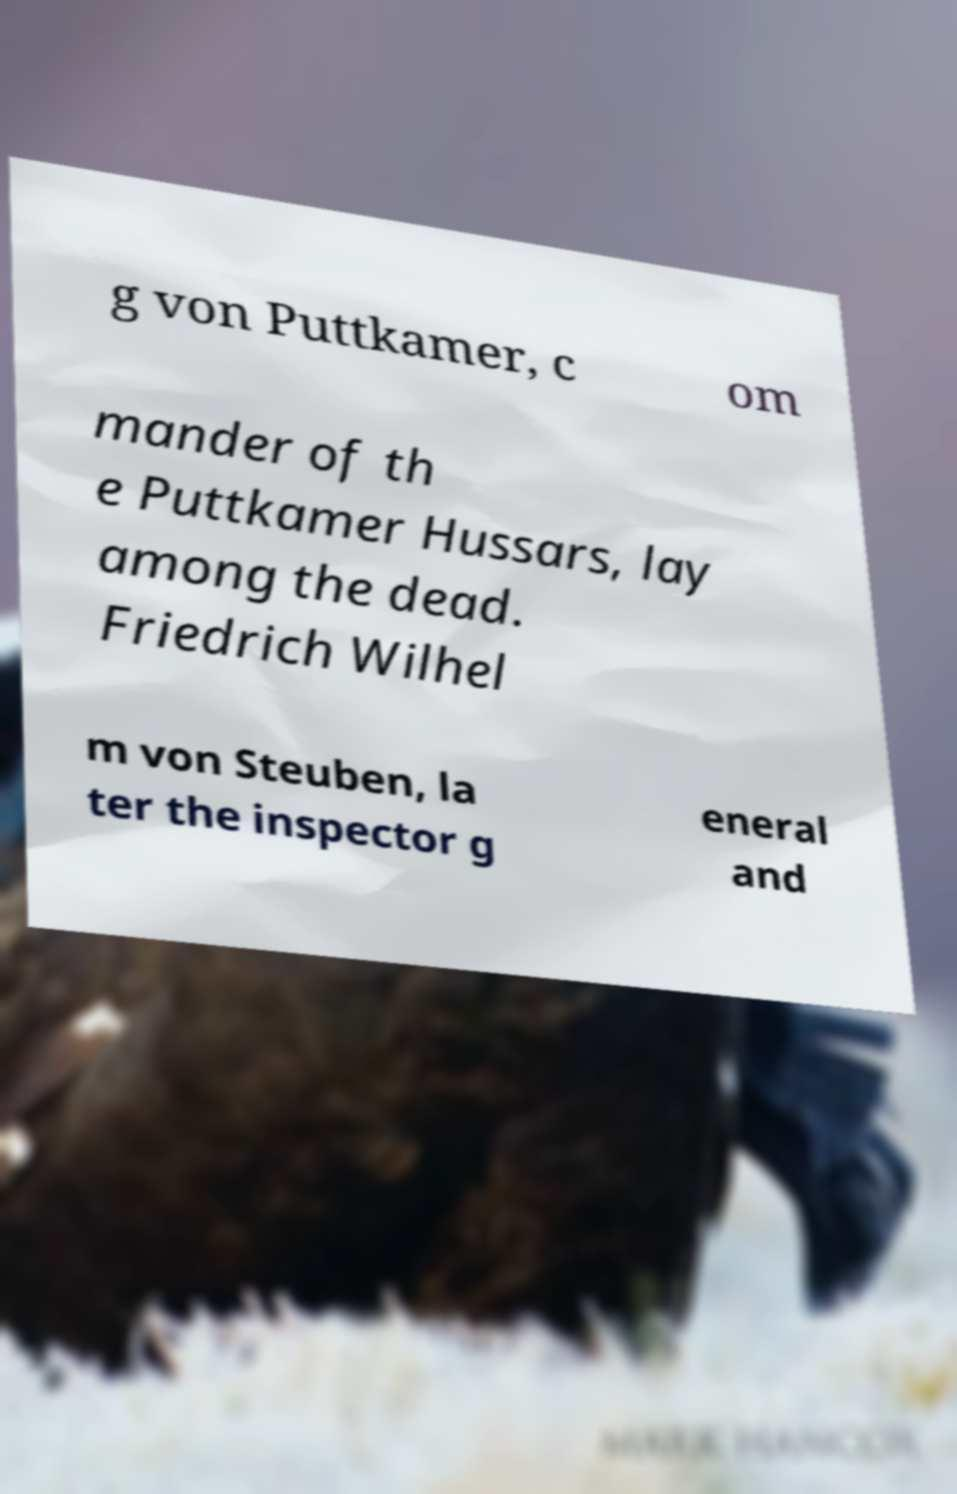Could you assist in decoding the text presented in this image and type it out clearly? g von Puttkamer, c om mander of th e Puttkamer Hussars, lay among the dead. Friedrich Wilhel m von Steuben, la ter the inspector g eneral and 